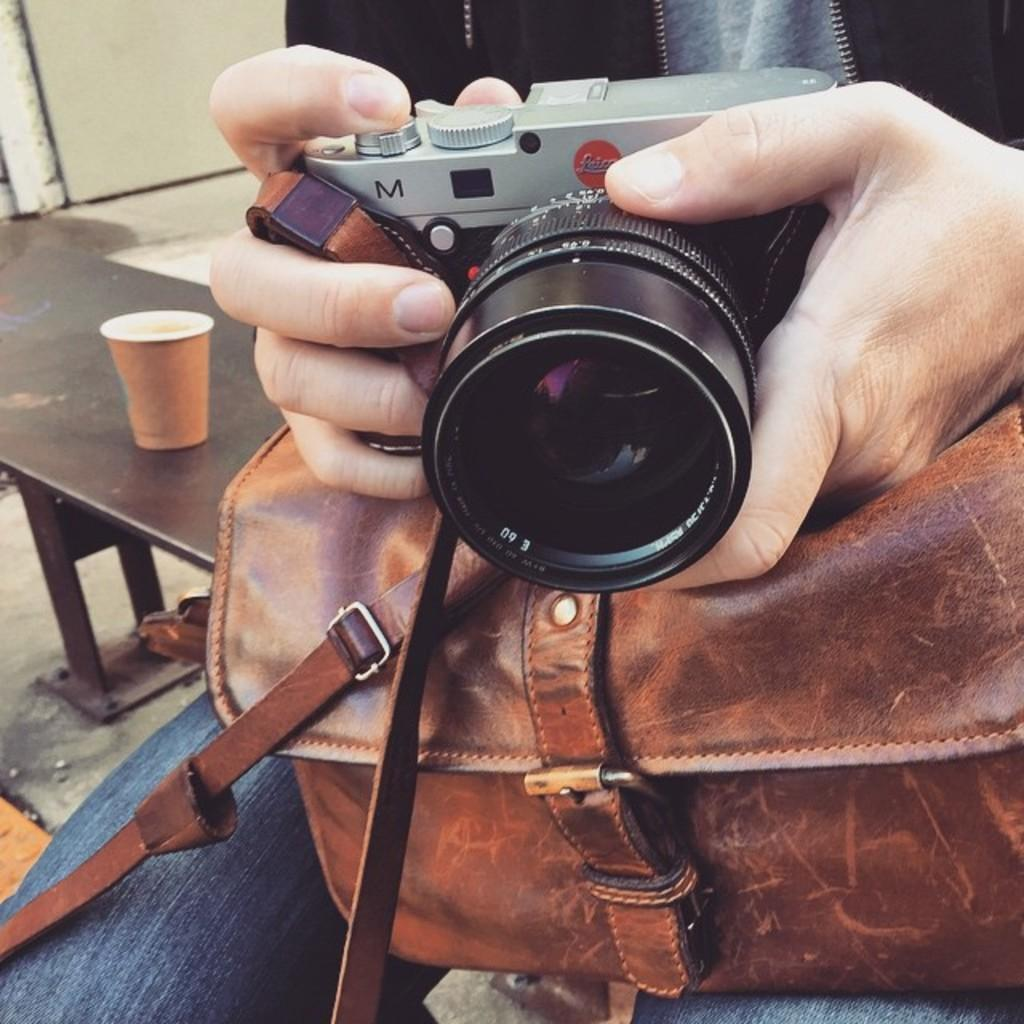Who is the main subject in the image? There is a person in the center of the image. What is the person holding in his hands? The person is holding a camera in his hands. What else is the person carrying in the image? The person has a bag on his laps. Can you describe the background of the image? There is a glass on a bench in the background area. What type of boundary can be seen in the image? There is no boundary present in the image. How does the person sort the items in the bag in the image? The image does not show the person sorting items in the bag, as the focus is on the person holding a camera. 